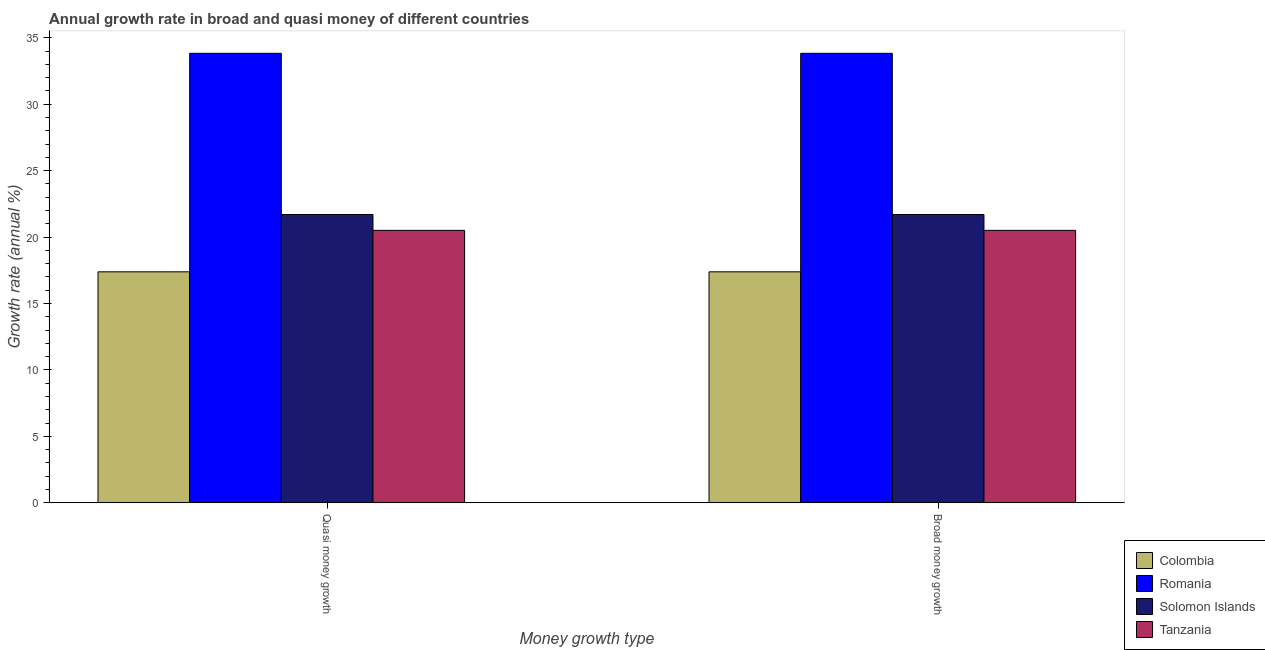Are the number of bars per tick equal to the number of legend labels?
Your answer should be very brief. Yes. What is the label of the 1st group of bars from the left?
Keep it short and to the point. Quasi money growth. What is the annual growth rate in broad money in Colombia?
Make the answer very short. 17.39. Across all countries, what is the maximum annual growth rate in quasi money?
Give a very brief answer. 33.83. Across all countries, what is the minimum annual growth rate in quasi money?
Keep it short and to the point. 17.39. In which country was the annual growth rate in broad money maximum?
Ensure brevity in your answer.  Romania. What is the total annual growth rate in quasi money in the graph?
Provide a succinct answer. 93.43. What is the difference between the annual growth rate in quasi money in Solomon Islands and that in Romania?
Offer a very short reply. -12.13. What is the difference between the annual growth rate in broad money in Tanzania and the annual growth rate in quasi money in Romania?
Ensure brevity in your answer.  -13.33. What is the average annual growth rate in broad money per country?
Keep it short and to the point. 23.36. What is the difference between the annual growth rate in broad money and annual growth rate in quasi money in Colombia?
Ensure brevity in your answer.  0. In how many countries, is the annual growth rate in quasi money greater than 2 %?
Your answer should be compact. 4. What is the ratio of the annual growth rate in broad money in Solomon Islands to that in Romania?
Your response must be concise. 0.64. In how many countries, is the annual growth rate in broad money greater than the average annual growth rate in broad money taken over all countries?
Make the answer very short. 1. What does the 1st bar from the left in Broad money growth represents?
Make the answer very short. Colombia. What does the 3rd bar from the right in Broad money growth represents?
Keep it short and to the point. Romania. How many bars are there?
Keep it short and to the point. 8. How many countries are there in the graph?
Your response must be concise. 4. Where does the legend appear in the graph?
Provide a succinct answer. Bottom right. What is the title of the graph?
Keep it short and to the point. Annual growth rate in broad and quasi money of different countries. What is the label or title of the X-axis?
Provide a succinct answer. Money growth type. What is the label or title of the Y-axis?
Provide a short and direct response. Growth rate (annual %). What is the Growth rate (annual %) of Colombia in Quasi money growth?
Provide a short and direct response. 17.39. What is the Growth rate (annual %) in Romania in Quasi money growth?
Keep it short and to the point. 33.83. What is the Growth rate (annual %) in Solomon Islands in Quasi money growth?
Your answer should be very brief. 21.7. What is the Growth rate (annual %) in Tanzania in Quasi money growth?
Make the answer very short. 20.51. What is the Growth rate (annual %) in Colombia in Broad money growth?
Ensure brevity in your answer.  17.39. What is the Growth rate (annual %) of Romania in Broad money growth?
Your answer should be very brief. 33.83. What is the Growth rate (annual %) in Solomon Islands in Broad money growth?
Make the answer very short. 21.7. What is the Growth rate (annual %) of Tanzania in Broad money growth?
Your answer should be very brief. 20.51. Across all Money growth type, what is the maximum Growth rate (annual %) of Colombia?
Your response must be concise. 17.39. Across all Money growth type, what is the maximum Growth rate (annual %) in Romania?
Keep it short and to the point. 33.83. Across all Money growth type, what is the maximum Growth rate (annual %) in Solomon Islands?
Ensure brevity in your answer.  21.7. Across all Money growth type, what is the maximum Growth rate (annual %) of Tanzania?
Provide a short and direct response. 20.51. Across all Money growth type, what is the minimum Growth rate (annual %) in Colombia?
Give a very brief answer. 17.39. Across all Money growth type, what is the minimum Growth rate (annual %) of Romania?
Keep it short and to the point. 33.83. Across all Money growth type, what is the minimum Growth rate (annual %) in Solomon Islands?
Your answer should be very brief. 21.7. Across all Money growth type, what is the minimum Growth rate (annual %) of Tanzania?
Offer a terse response. 20.51. What is the total Growth rate (annual %) of Colombia in the graph?
Your answer should be very brief. 34.77. What is the total Growth rate (annual %) of Romania in the graph?
Offer a terse response. 67.67. What is the total Growth rate (annual %) of Solomon Islands in the graph?
Offer a terse response. 43.4. What is the total Growth rate (annual %) of Tanzania in the graph?
Your answer should be compact. 41.02. What is the difference between the Growth rate (annual %) of Solomon Islands in Quasi money growth and that in Broad money growth?
Ensure brevity in your answer.  0. What is the difference between the Growth rate (annual %) of Colombia in Quasi money growth and the Growth rate (annual %) of Romania in Broad money growth?
Give a very brief answer. -16.45. What is the difference between the Growth rate (annual %) of Colombia in Quasi money growth and the Growth rate (annual %) of Solomon Islands in Broad money growth?
Offer a very short reply. -4.31. What is the difference between the Growth rate (annual %) in Colombia in Quasi money growth and the Growth rate (annual %) in Tanzania in Broad money growth?
Your response must be concise. -3.12. What is the difference between the Growth rate (annual %) of Romania in Quasi money growth and the Growth rate (annual %) of Solomon Islands in Broad money growth?
Your answer should be compact. 12.13. What is the difference between the Growth rate (annual %) of Romania in Quasi money growth and the Growth rate (annual %) of Tanzania in Broad money growth?
Your answer should be very brief. 13.33. What is the difference between the Growth rate (annual %) in Solomon Islands in Quasi money growth and the Growth rate (annual %) in Tanzania in Broad money growth?
Ensure brevity in your answer.  1.19. What is the average Growth rate (annual %) of Colombia per Money growth type?
Ensure brevity in your answer.  17.39. What is the average Growth rate (annual %) of Romania per Money growth type?
Provide a short and direct response. 33.83. What is the average Growth rate (annual %) in Solomon Islands per Money growth type?
Your response must be concise. 21.7. What is the average Growth rate (annual %) in Tanzania per Money growth type?
Keep it short and to the point. 20.51. What is the difference between the Growth rate (annual %) in Colombia and Growth rate (annual %) in Romania in Quasi money growth?
Make the answer very short. -16.45. What is the difference between the Growth rate (annual %) of Colombia and Growth rate (annual %) of Solomon Islands in Quasi money growth?
Give a very brief answer. -4.31. What is the difference between the Growth rate (annual %) of Colombia and Growth rate (annual %) of Tanzania in Quasi money growth?
Make the answer very short. -3.12. What is the difference between the Growth rate (annual %) in Romania and Growth rate (annual %) in Solomon Islands in Quasi money growth?
Your answer should be very brief. 12.13. What is the difference between the Growth rate (annual %) of Romania and Growth rate (annual %) of Tanzania in Quasi money growth?
Provide a succinct answer. 13.33. What is the difference between the Growth rate (annual %) in Solomon Islands and Growth rate (annual %) in Tanzania in Quasi money growth?
Your response must be concise. 1.19. What is the difference between the Growth rate (annual %) in Colombia and Growth rate (annual %) in Romania in Broad money growth?
Offer a terse response. -16.45. What is the difference between the Growth rate (annual %) of Colombia and Growth rate (annual %) of Solomon Islands in Broad money growth?
Offer a very short reply. -4.31. What is the difference between the Growth rate (annual %) of Colombia and Growth rate (annual %) of Tanzania in Broad money growth?
Offer a terse response. -3.12. What is the difference between the Growth rate (annual %) in Romania and Growth rate (annual %) in Solomon Islands in Broad money growth?
Keep it short and to the point. 12.13. What is the difference between the Growth rate (annual %) in Romania and Growth rate (annual %) in Tanzania in Broad money growth?
Your answer should be very brief. 13.33. What is the difference between the Growth rate (annual %) in Solomon Islands and Growth rate (annual %) in Tanzania in Broad money growth?
Offer a very short reply. 1.19. What is the ratio of the Growth rate (annual %) of Romania in Quasi money growth to that in Broad money growth?
Give a very brief answer. 1. What is the ratio of the Growth rate (annual %) of Solomon Islands in Quasi money growth to that in Broad money growth?
Your answer should be very brief. 1. What is the ratio of the Growth rate (annual %) in Tanzania in Quasi money growth to that in Broad money growth?
Your response must be concise. 1. What is the difference between the highest and the second highest Growth rate (annual %) in Tanzania?
Offer a terse response. 0. What is the difference between the highest and the lowest Growth rate (annual %) in Colombia?
Give a very brief answer. 0. What is the difference between the highest and the lowest Growth rate (annual %) in Romania?
Give a very brief answer. 0. What is the difference between the highest and the lowest Growth rate (annual %) of Solomon Islands?
Your answer should be compact. 0. 